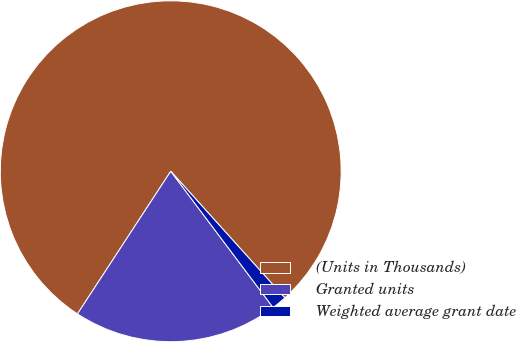Convert chart. <chart><loc_0><loc_0><loc_500><loc_500><pie_chart><fcel>(Units in Thousands)<fcel>Granted units<fcel>Weighted average grant date<nl><fcel>79.11%<fcel>19.47%<fcel>1.42%<nl></chart> 